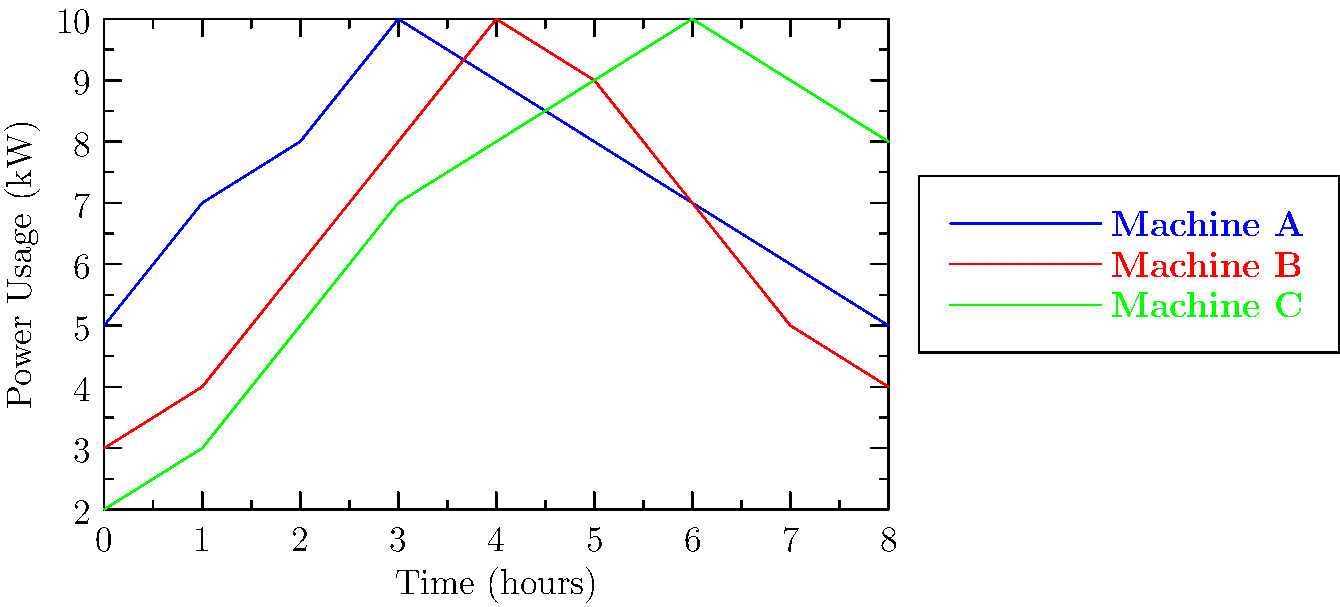A factory owner is considering replacing their current equipment with more energy-efficient models. The graph shows the power usage of three different machines over an 8-hour production cycle. As a sales representative, which machine would you recommend to the factory owner if their primary concern is minimizing total energy consumption, and why? To determine which machine consumes the least amount of energy over the 8-hour cycle, we need to calculate the area under each curve, which represents the total energy consumed.

Step 1: Estimate the area under each curve using the trapezoidal rule.

For Machine A:
$$\text{Area}_A = \frac{1}{2}(5+5 + 2(7+8+10+9+8+7+6)) = 60.5$$

For Machine B:
$$\text{Area}_B = \frac{1}{2}(3+4 + 2(4+6+8+10+9+7+5)) = 56$$

For Machine C:
$$\text{Area}_C = \frac{1}{2}(2+8 + 2(3+5+7+8+9+10+9)) = 61$$

Step 2: Convert the areas to energy consumption.
Since power is measured in kW and time in hours, the areas represent energy in kWh.

Machine A: 60.5 kWh
Machine B: 56 kWh
Machine C: 61 kWh

Step 3: Compare the total energy consumption.
Machine B has the lowest total energy consumption at 56 kWh.

Step 4: Consider other factors.
While Machine B has the lowest total energy consumption, it's worth noting that it has the highest peak power usage (10 kW). Depending on the factory's electrical infrastructure and peak demand charges, this could be a consideration.

However, given that the primary concern is minimizing total energy consumption, Machine B would be the recommended choice.
Answer: Machine B, as it consumes the least total energy (56 kWh) over the 8-hour cycle. 